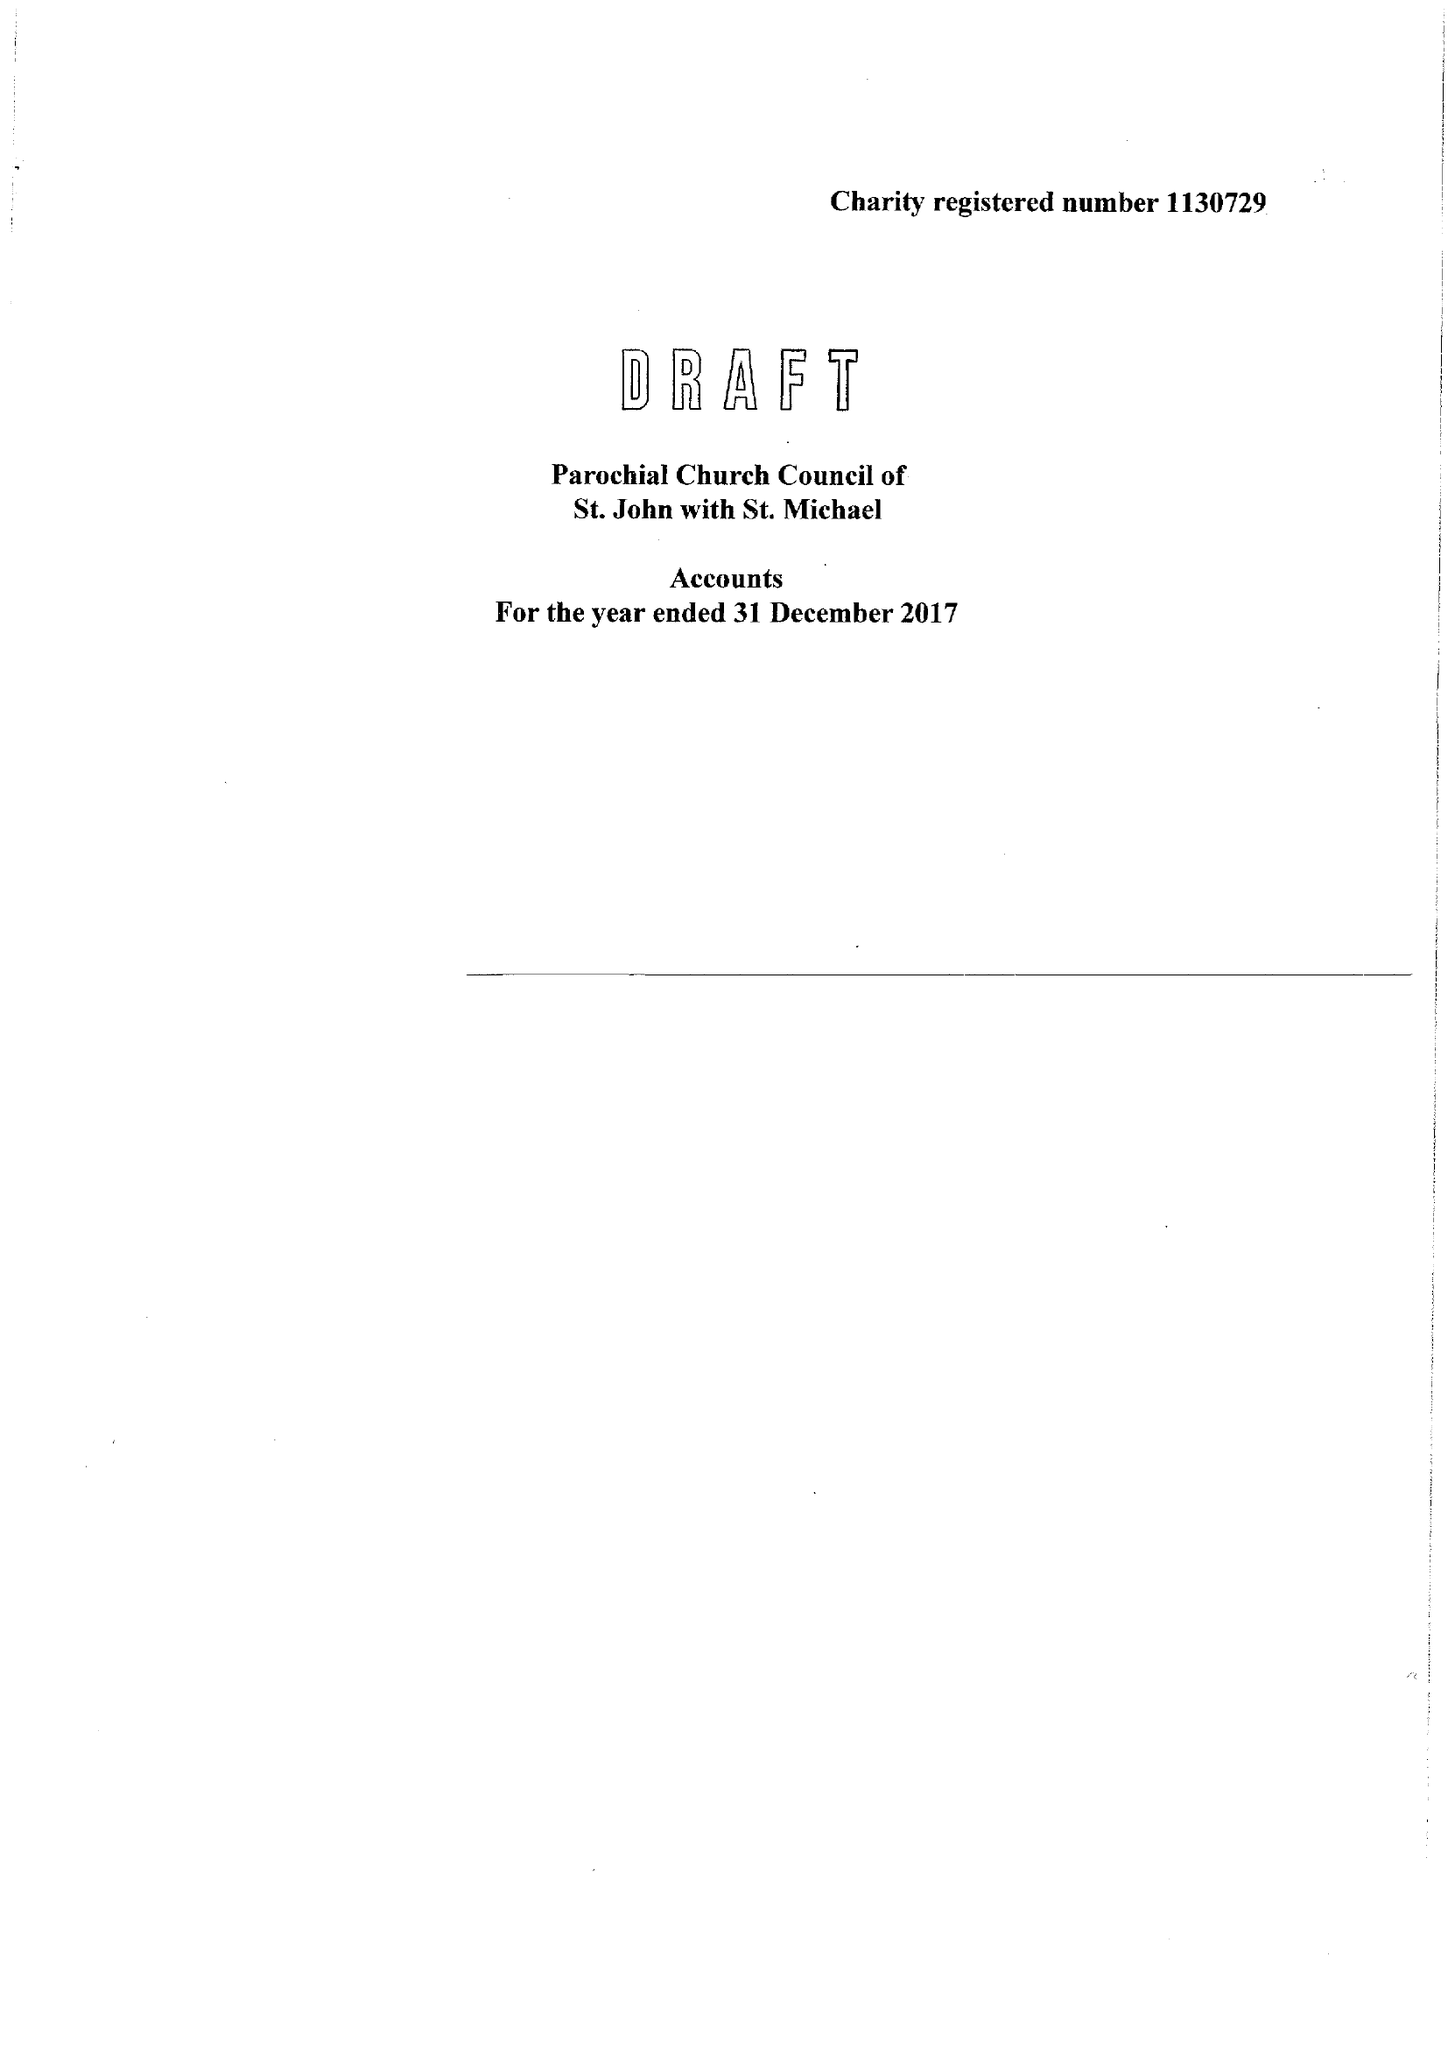What is the value for the address__post_town?
Answer the question using a single word or phrase. None 